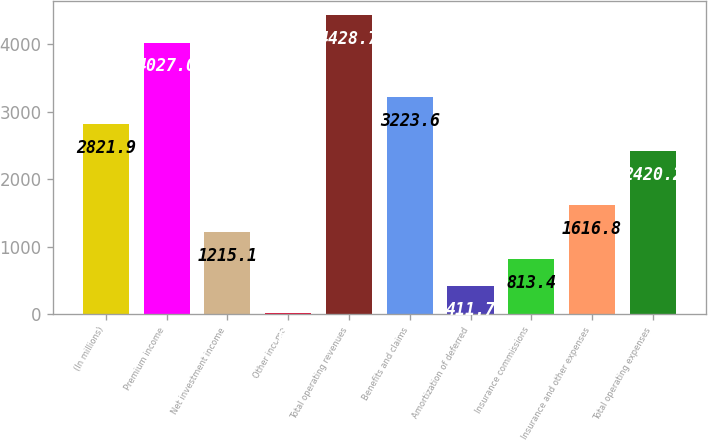<chart> <loc_0><loc_0><loc_500><loc_500><bar_chart><fcel>(In millions)<fcel>Premium income<fcel>Net investment income<fcel>Other income<fcel>Total operating revenues<fcel>Benefits and claims<fcel>Amortization of deferred<fcel>Insurance commissions<fcel>Insurance and other expenses<fcel>Total operating expenses<nl><fcel>2821.9<fcel>4027<fcel>1215.1<fcel>10<fcel>4428.7<fcel>3223.6<fcel>411.7<fcel>813.4<fcel>1616.8<fcel>2420.2<nl></chart> 